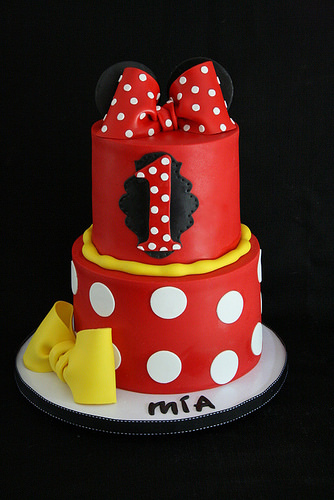<image>
Can you confirm if the bow is on the cake? Yes. Looking at the image, I can see the bow is positioned on top of the cake, with the cake providing support. 